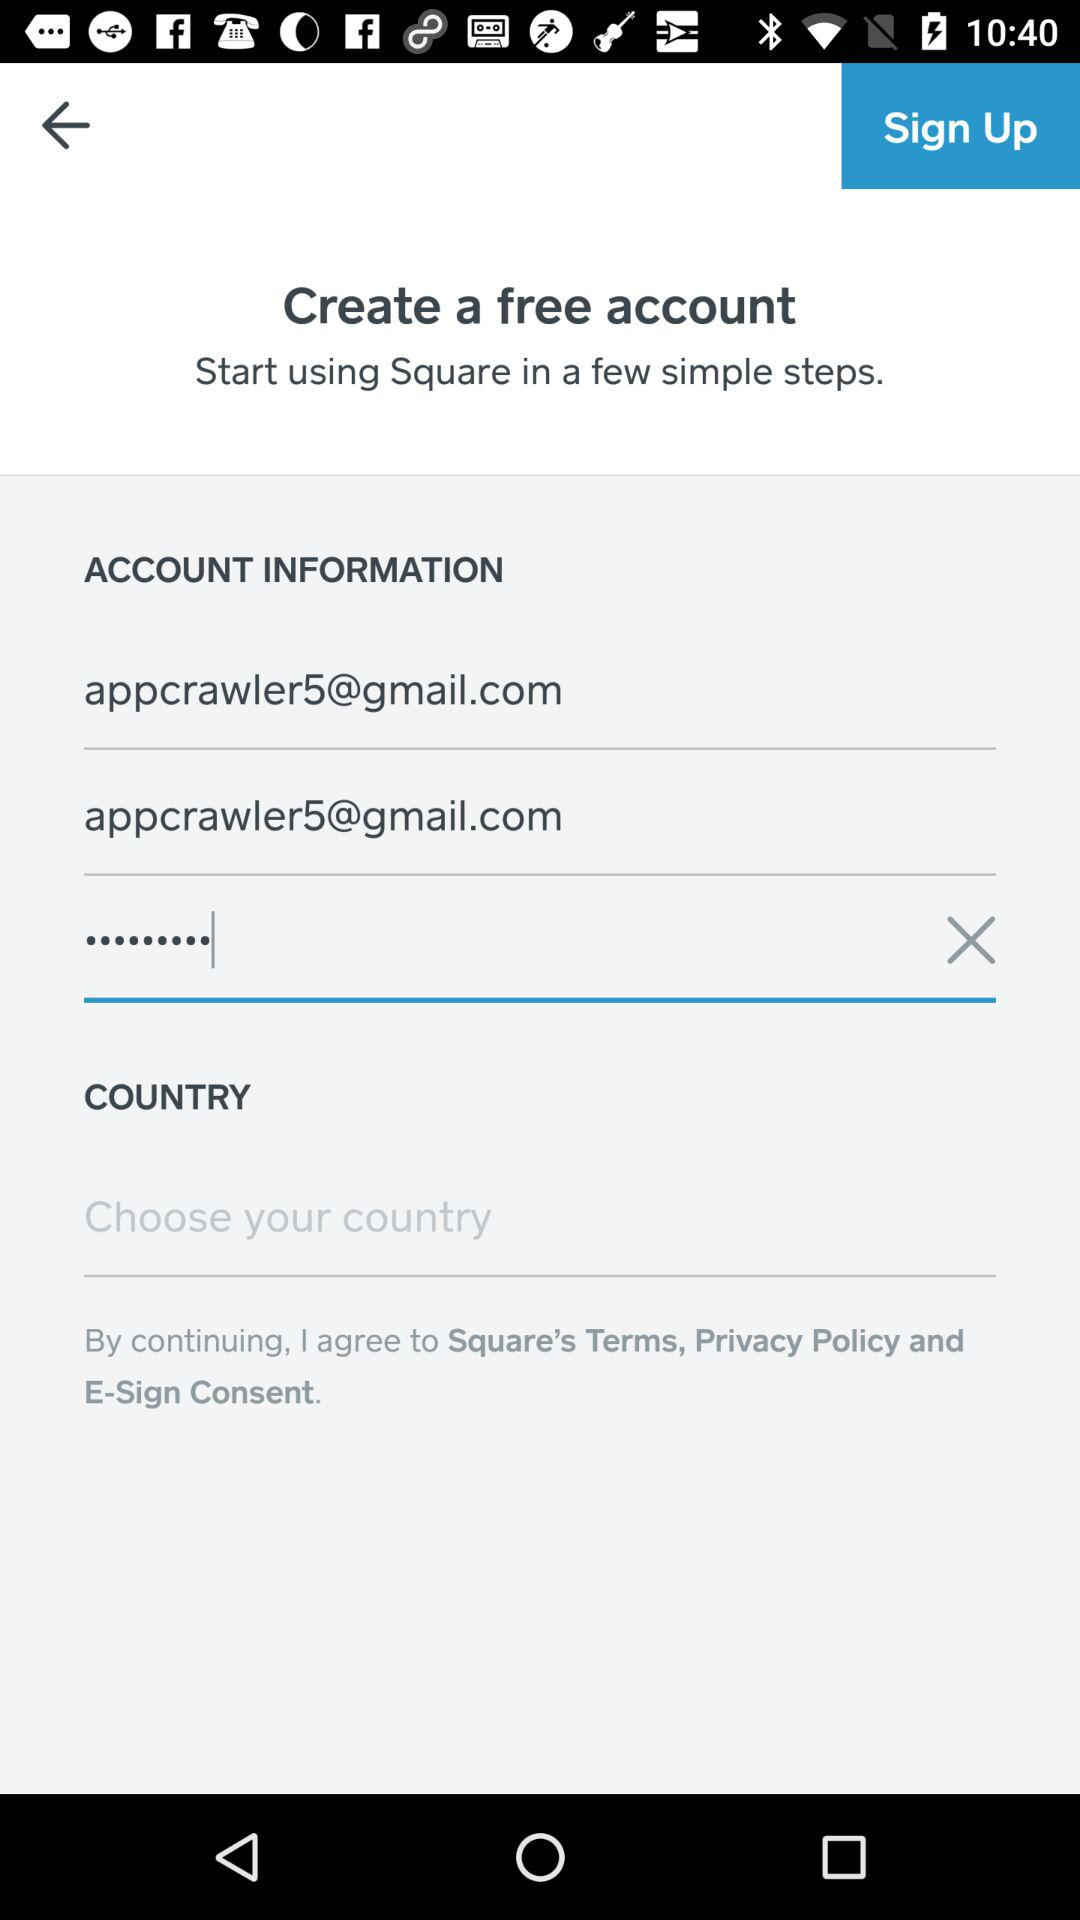What is the email address of the user? The email address of the user is appcrawler5@gmail.com. 